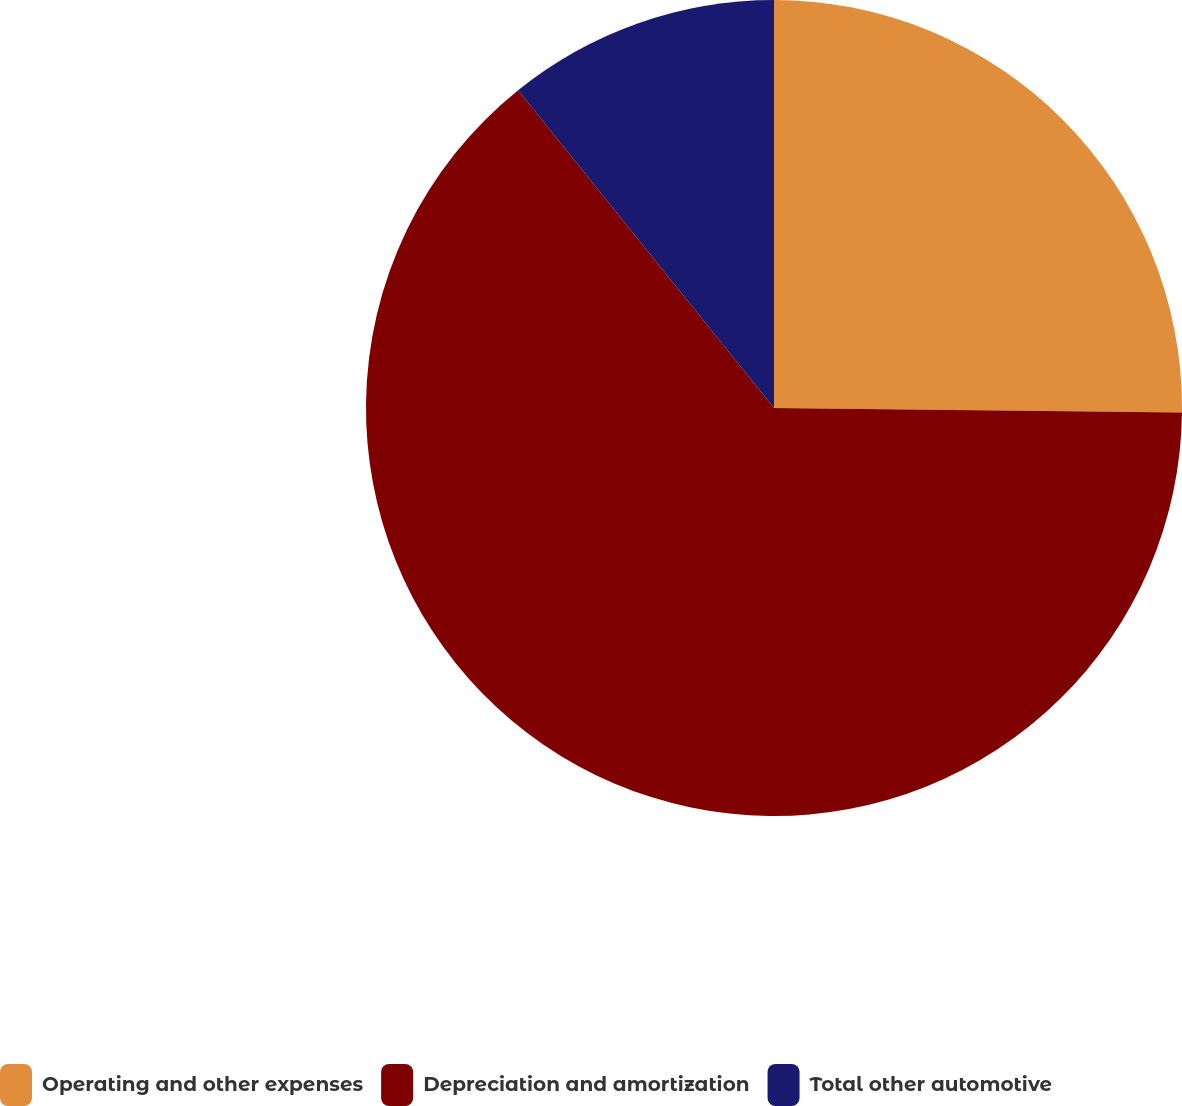Convert chart. <chart><loc_0><loc_0><loc_500><loc_500><pie_chart><fcel>Operating and other expenses<fcel>Depreciation and amortization<fcel>Total other automotive<nl><fcel>25.18%<fcel>64.03%<fcel>10.79%<nl></chart> 